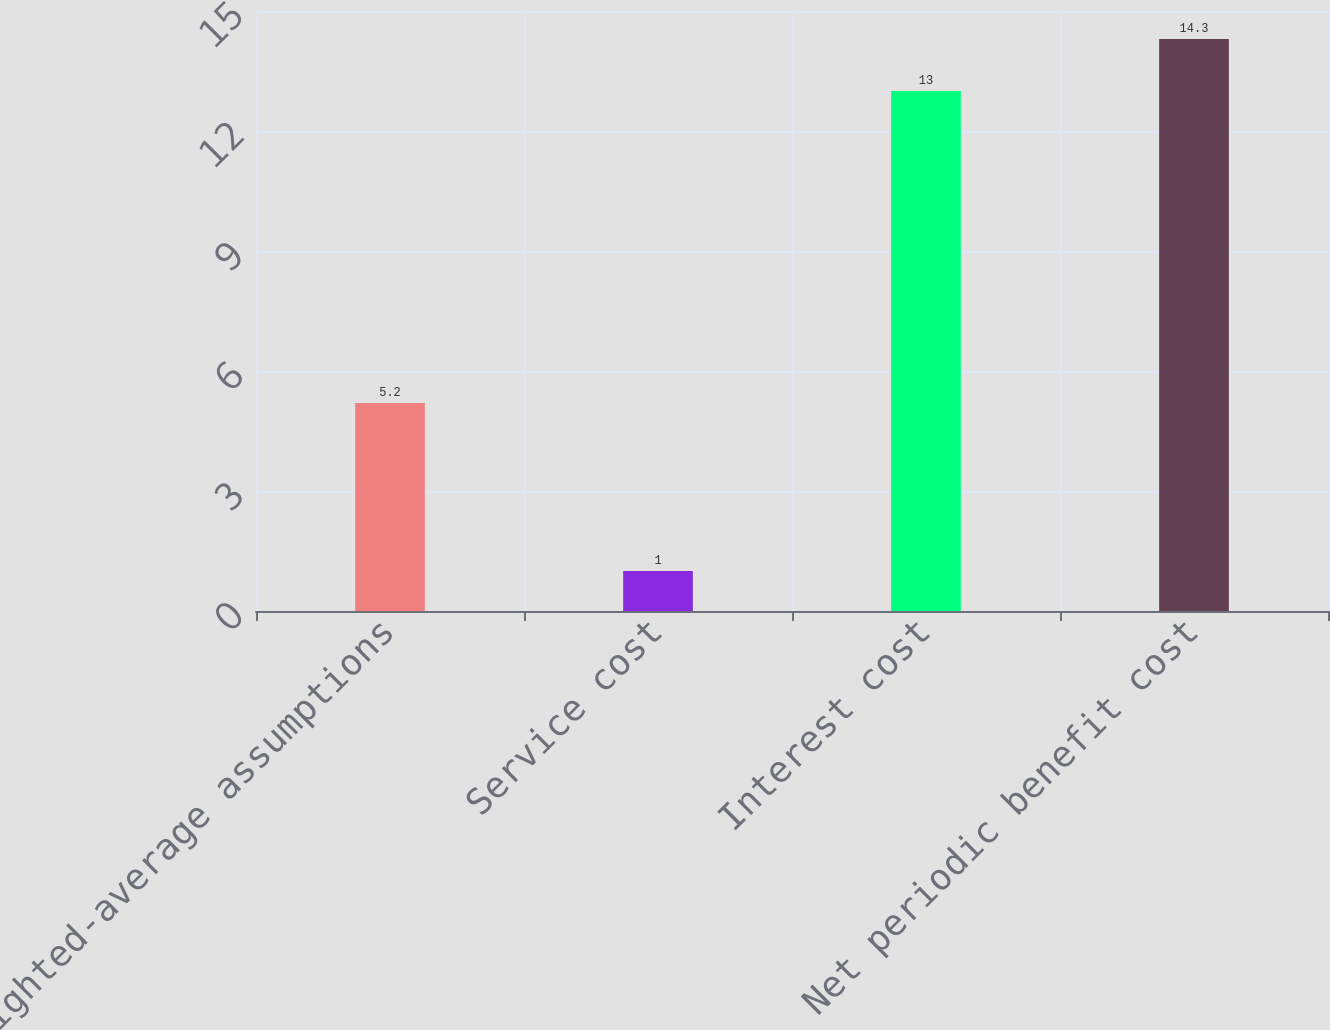Convert chart. <chart><loc_0><loc_0><loc_500><loc_500><bar_chart><fcel>Weighted-average assumptions<fcel>Service cost<fcel>Interest cost<fcel>Net periodic benefit cost<nl><fcel>5.2<fcel>1<fcel>13<fcel>14.3<nl></chart> 